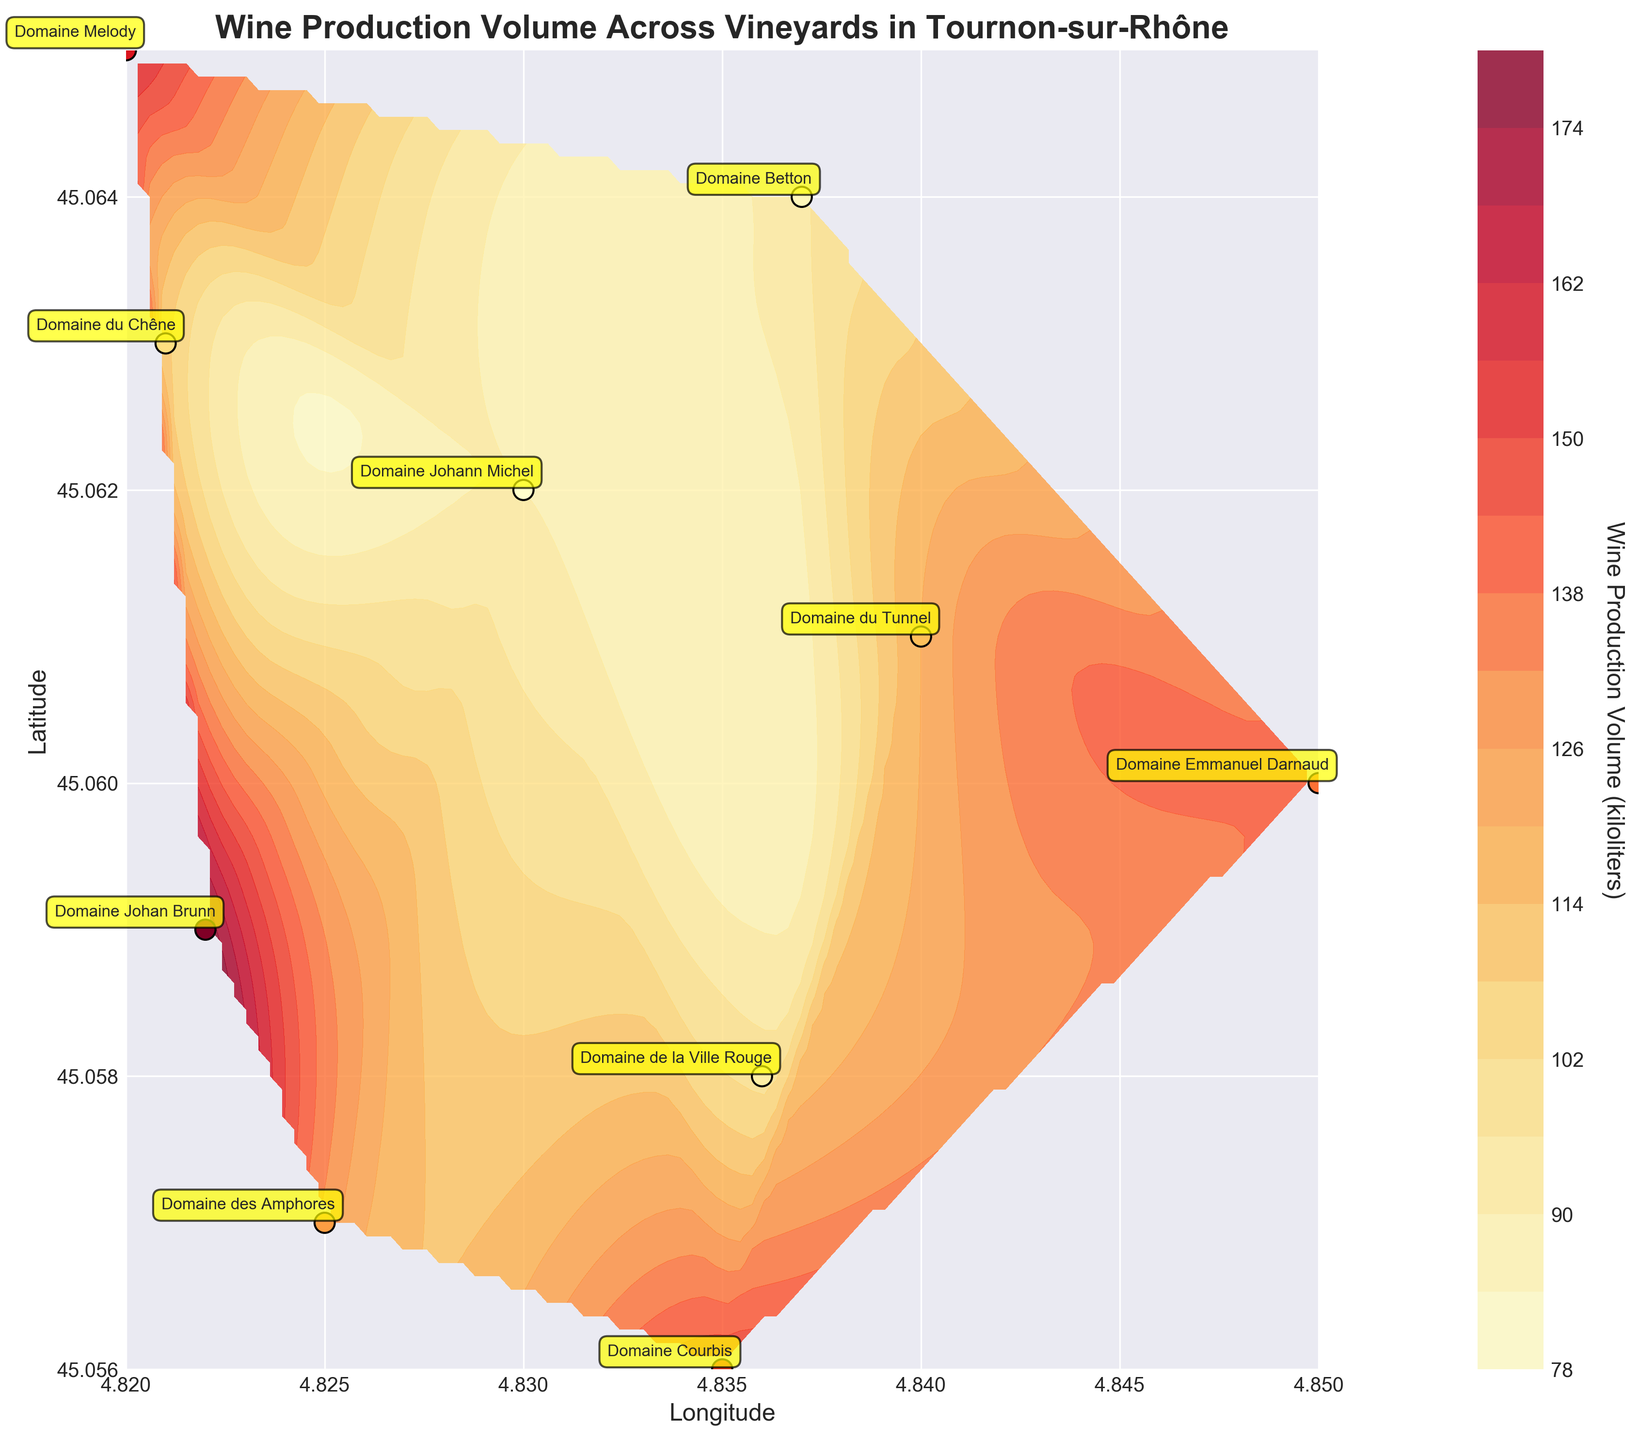What is the title of the figure? The title of the figure is displayed at the top center of the plot. It gives an overview of what the figure represents.
Answer: Wine Production Volume Across Vineyards in Tournon-sur-Rhône Which vineyard has the highest wine production volume? By looking at the annotated labels and checking the color gradient that corresponds with higher production, you can see Domaine Johan Brunn has the darkest shade, indicating the highest volume.
Answer: Domaine Johan Brunn What is the total wine production volume of all the vineyards? Add the wine production volumes of each vineyard: 150 + 120 + 90 + 130 + 140 + 110 + 100 + 180 + 95 + 160 = 1275 kiloliters.
Answer: 1275 kiloliters Which vineyard is located at the northernmost point? By examining the latitude values, the northernmost is the one with the highest latitude. Domaine Melody, at a latitude of 45.065, is the northernmost.
Answer: Domaine Melody How does the wine production volume at Domaine Betton compare to Domaine des Amphores? Locate Domaine Betton and Domaine des Amphores on the figure and compare their production volumes (95 kiloliters for Domaine Betton and 130 kiloliters for Domaine des Amphores). Domaine des Amphores produces more wine.
Answer: Domaine des Amphores produces more wine Which vineyard is closest to Domaine Emmanuel Darnaud in terms of geographical location? Look at the scatter plot points and locate the closest neighbor to Domaine Emmanuel Darnaud (latitude 45.060, longitude 4.850). Domaine du Tunnel, located at (latitude 45.061, longitude 4.840), is geographically closest.
Answer: Domaine du Tunnel What is the average wine production volume of the vineyards located west of 4.830 longitude? The vineyards are Domaine des Amphores (130), Domaine Johan Brunn (180), and Domaine Melody (160). The average is (130+180+160)/3 = 470/3 ≈ 156.7 kiloliters.
Answer: 156.7 kiloliters Which vineyard has the smallest wine production volume and where is it located? By reading the labels and checking the color map, the smallest production volume is Domaine Johann Michel with 90 kiloliters, located at (latitude 45.062, longitude 4.830).
Answer: Domaine Johann Michel at (45.062, 4.830) How many vineyards produce wine volumes in excess of 120 kiloliters? Identify the vineyards with production volumes greater than 120: Domaine Courbis (150), Domaine Emmanuel Darnaud (140), Domaine Johan Brunn (180), and Domaine Melody (160). There are 4 vineyards.
Answer: 4 What's the latitude and longitude range covered by the vineyards in the plot? The latitude range is from 45.056 to 45.065 and the longitude range is from 4.820 to 4.850, based on the distribution of the scatter points on the plot.
Answer: Latitude: 45.056 to 45.065, Longitude: 4.820 to 4.850 